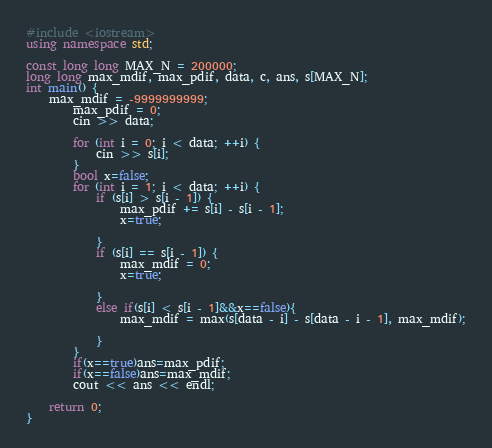Convert code to text. <code><loc_0><loc_0><loc_500><loc_500><_C++_>#include <iostream>
using namespace std;

const long long MAX_N = 200000;
long long max_mdif, max_pdif, data, c, ans, s[MAX_N];
int main() {
	max_mdif = -9999999999;
		max_pdif = 0;
		cin >> data;

		for (int i = 0; i < data; ++i) {
			cin >> s[i];
		}
		bool x=false;
		for (int i = 1; i < data; ++i) {
			if (s[i] > s[i - 1]) {
				max_pdif += s[i] - s[i - 1];
				x=true;

			}
			if (s[i] == s[i - 1]) {
				max_mdif = 0;
				x=true;

			}
			else if(s[i] < s[i - 1]&&x==false){
				max_mdif = max(s[data - i] - s[data - i - 1], max_mdif);

			}
		}
		if(x==true)ans=max_pdif;
		if(x==false)ans=max_mdif;
		cout << ans << endl;

	return 0;
}</code> 